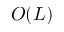Convert formula to latex. <formula><loc_0><loc_0><loc_500><loc_500>O ( L )</formula> 